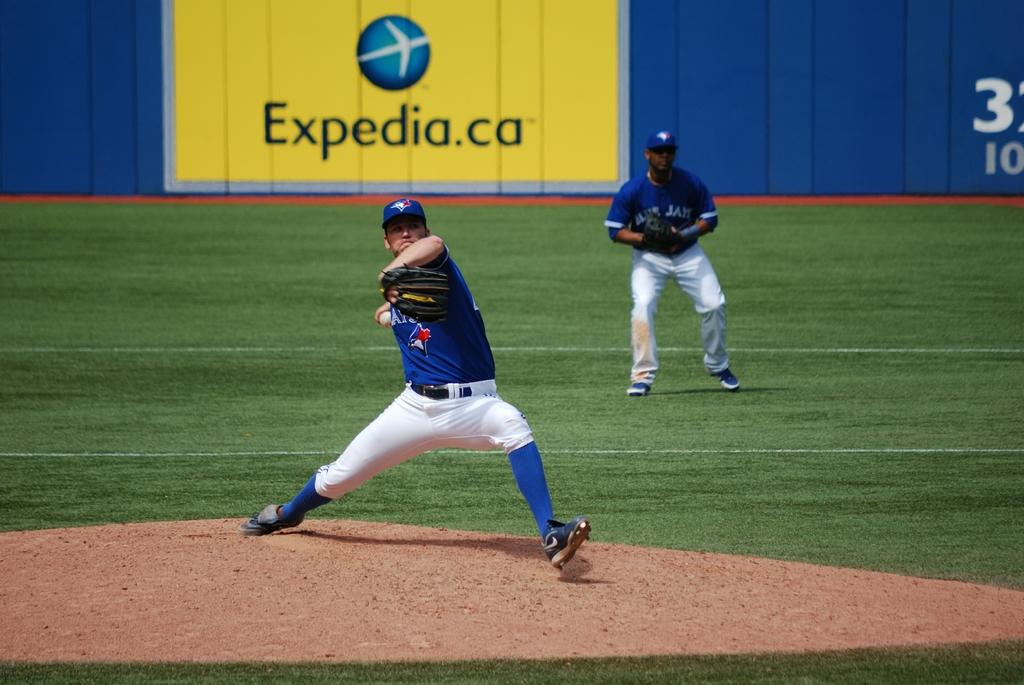Provide a one-sentence caption for the provided image. A baseball pitching is throwing the ball with an advertising for Expedia in the background. 